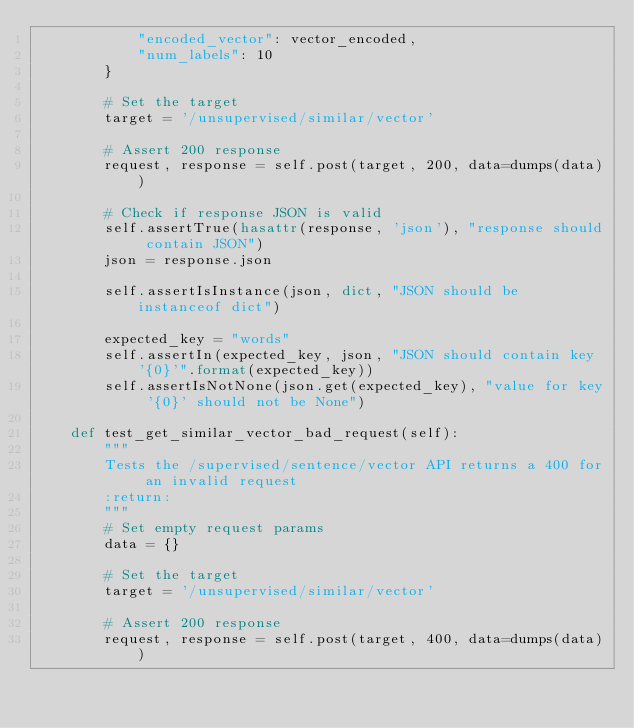Convert code to text. <code><loc_0><loc_0><loc_500><loc_500><_Python_>            "encoded_vector": vector_encoded,
            "num_labels": 10
        }

        # Set the target
        target = '/unsupervised/similar/vector'

        # Assert 200 response
        request, response = self.post(target, 200, data=dumps(data))

        # Check if response JSON is valid
        self.assertTrue(hasattr(response, 'json'), "response should contain JSON")
        json = response.json

        self.assertIsInstance(json, dict, "JSON should be instanceof dict")

        expected_key = "words"
        self.assertIn(expected_key, json, "JSON should contain key '{0}'".format(expected_key))
        self.assertIsNotNone(json.get(expected_key), "value for key '{0}' should not be None")

    def test_get_similar_vector_bad_request(self):
        """
        Tests the /supervised/sentence/vector API returns a 400 for an invalid request
        :return:
        """
        # Set empty request params
        data = {}

        # Set the target
        target = '/unsupervised/similar/vector'

        # Assert 200 response
        request, response = self.post(target, 400, data=dumps(data))
</code> 